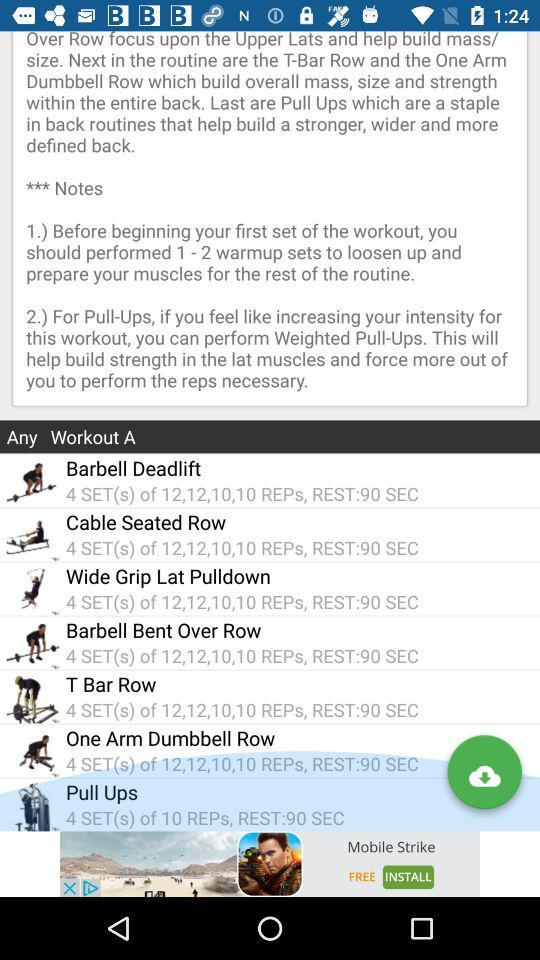How many sets are there for Wide Grip Lat Pulldown?
Answer the question using a single word or phrase. 4 